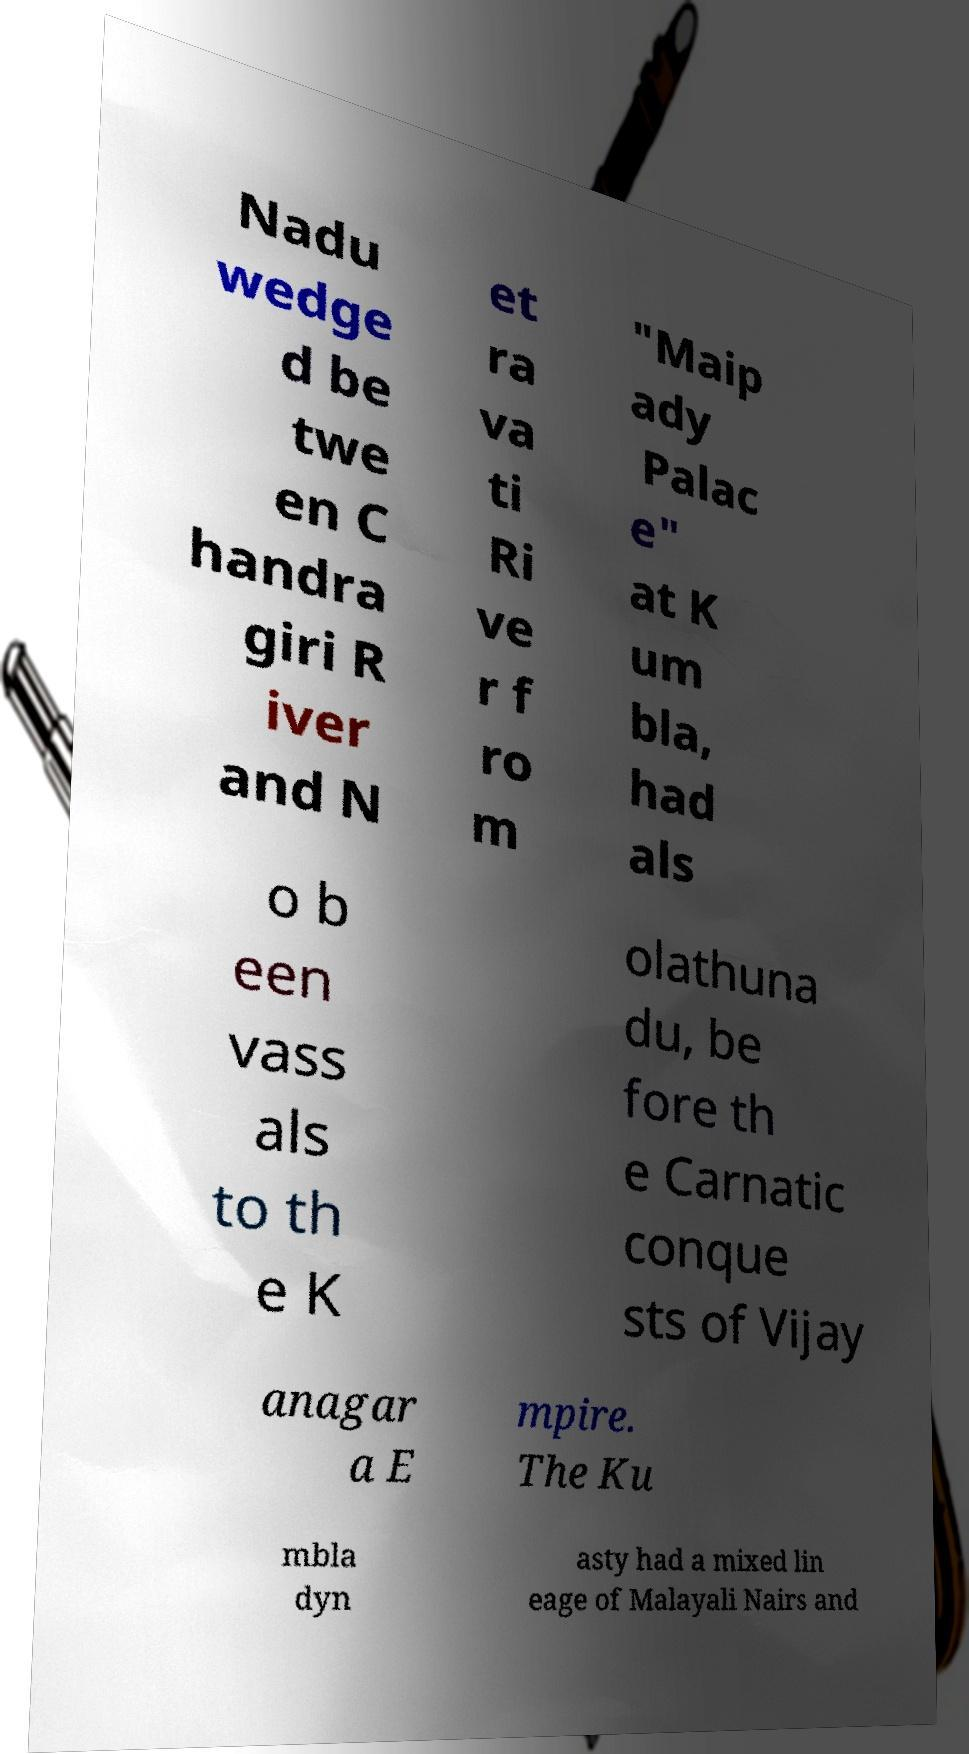Could you assist in decoding the text presented in this image and type it out clearly? Nadu wedge d be twe en C handra giri R iver and N et ra va ti Ri ve r f ro m "Maip ady Palac e" at K um bla, had als o b een vass als to th e K olathuna du, be fore th e Carnatic conque sts of Vijay anagar a E mpire. The Ku mbla dyn asty had a mixed lin eage of Malayali Nairs and 